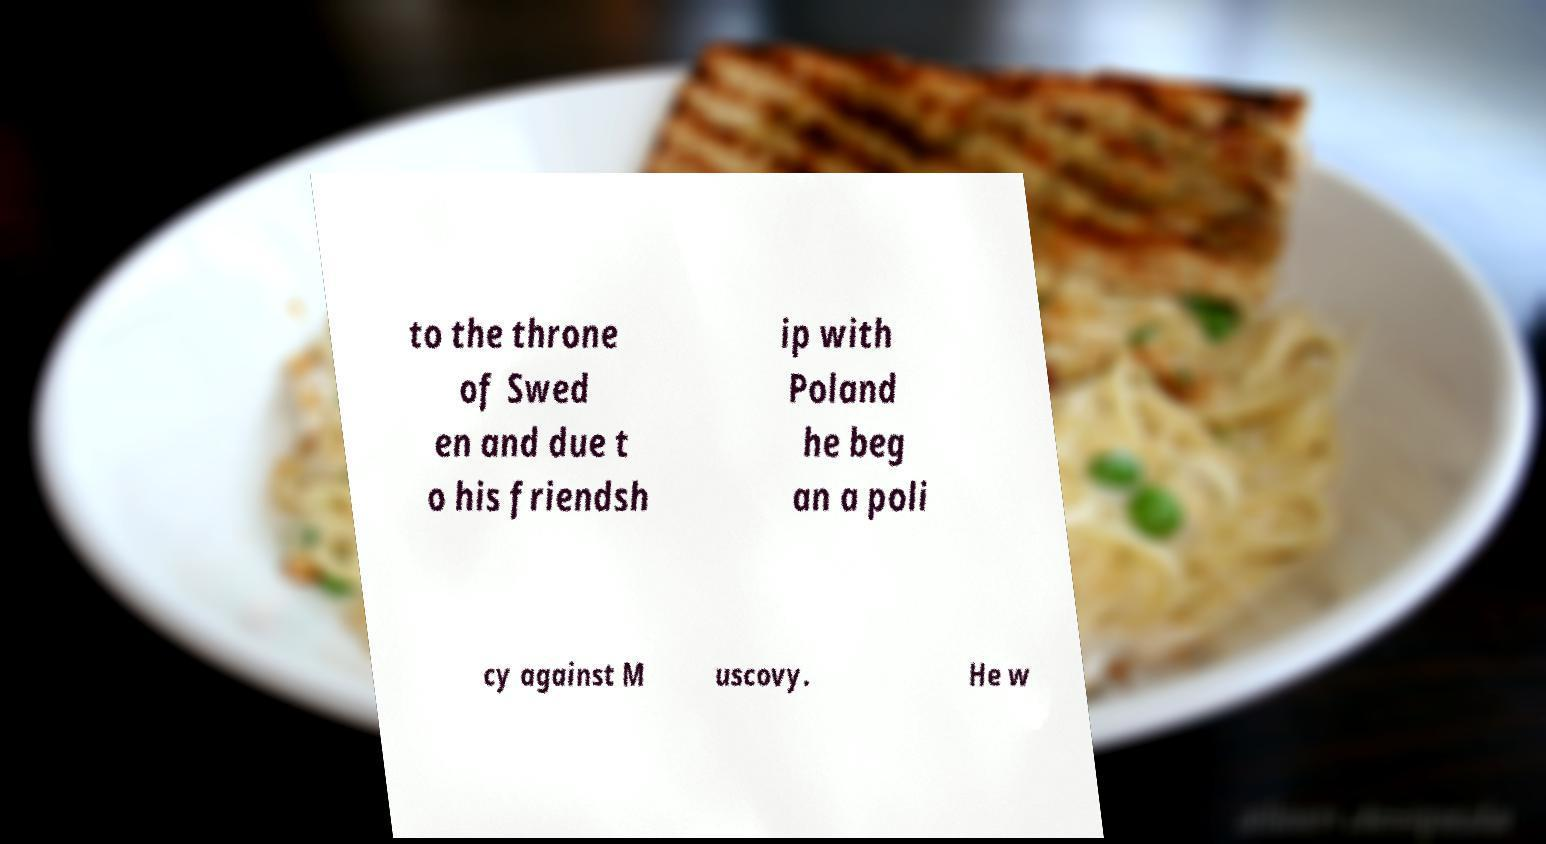There's text embedded in this image that I need extracted. Can you transcribe it verbatim? to the throne of Swed en and due t o his friendsh ip with Poland he beg an a poli cy against M uscovy. He w 